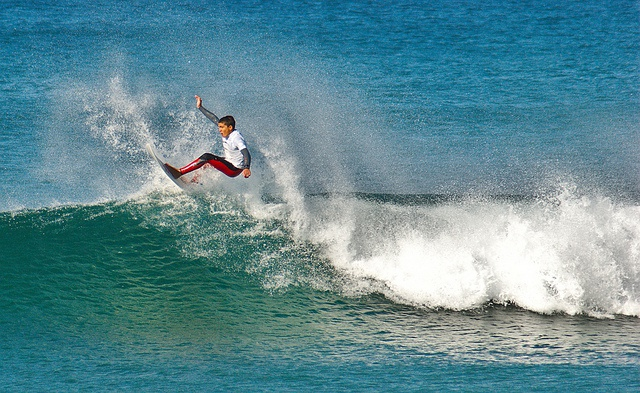Describe the objects in this image and their specific colors. I can see people in teal, lightgray, black, gray, and maroon tones and surfboard in teal, darkgray, gray, and lightgray tones in this image. 